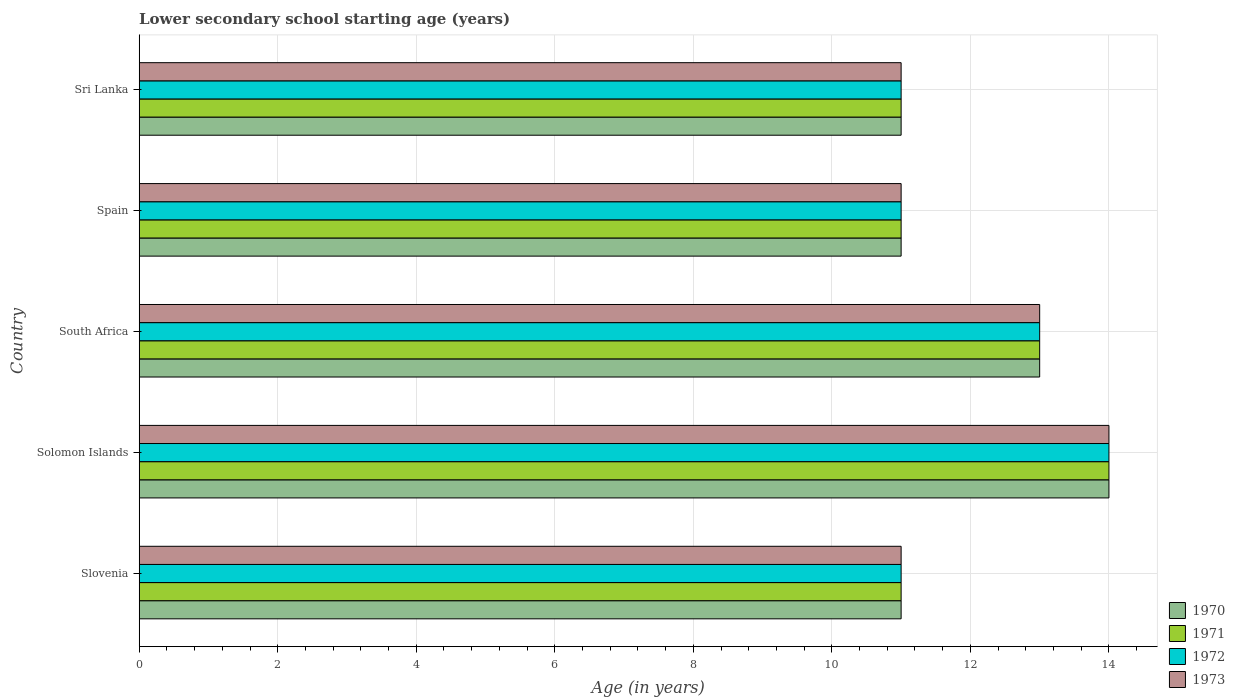How many different coloured bars are there?
Provide a succinct answer. 4. How many groups of bars are there?
Keep it short and to the point. 5. Are the number of bars per tick equal to the number of legend labels?
Give a very brief answer. Yes. How many bars are there on the 4th tick from the bottom?
Provide a short and direct response. 4. What is the label of the 3rd group of bars from the top?
Offer a very short reply. South Africa. In how many cases, is the number of bars for a given country not equal to the number of legend labels?
Make the answer very short. 0. Across all countries, what is the maximum lower secondary school starting age of children in 1971?
Your answer should be compact. 14. Across all countries, what is the minimum lower secondary school starting age of children in 1973?
Keep it short and to the point. 11. In which country was the lower secondary school starting age of children in 1970 maximum?
Provide a succinct answer. Solomon Islands. In which country was the lower secondary school starting age of children in 1972 minimum?
Make the answer very short. Slovenia. What is the difference between the lower secondary school starting age of children in 1970 in Slovenia and the lower secondary school starting age of children in 1971 in Sri Lanka?
Provide a short and direct response. 0. What is the average lower secondary school starting age of children in 1971 per country?
Your answer should be compact. 12. What is the difference between the lower secondary school starting age of children in 1970 and lower secondary school starting age of children in 1973 in South Africa?
Your answer should be very brief. 0. In how many countries, is the lower secondary school starting age of children in 1971 greater than 4.4 years?
Provide a succinct answer. 5. What is the ratio of the lower secondary school starting age of children in 1972 in Solomon Islands to that in South Africa?
Your response must be concise. 1.08. Is the difference between the lower secondary school starting age of children in 1970 in Slovenia and South Africa greater than the difference between the lower secondary school starting age of children in 1973 in Slovenia and South Africa?
Provide a short and direct response. No. In how many countries, is the lower secondary school starting age of children in 1973 greater than the average lower secondary school starting age of children in 1973 taken over all countries?
Make the answer very short. 2. What does the 4th bar from the bottom in Slovenia represents?
Make the answer very short. 1973. How are the legend labels stacked?
Provide a succinct answer. Vertical. What is the title of the graph?
Your response must be concise. Lower secondary school starting age (years). Does "1978" appear as one of the legend labels in the graph?
Give a very brief answer. No. What is the label or title of the X-axis?
Make the answer very short. Age (in years). What is the Age (in years) of 1972 in Slovenia?
Your response must be concise. 11. What is the Age (in years) of 1970 in Solomon Islands?
Offer a terse response. 14. What is the Age (in years) of 1972 in Solomon Islands?
Offer a very short reply. 14. What is the Age (in years) of 1970 in South Africa?
Keep it short and to the point. 13. What is the Age (in years) in 1973 in South Africa?
Your answer should be very brief. 13. What is the Age (in years) of 1971 in Spain?
Your response must be concise. 11. What is the Age (in years) of 1972 in Spain?
Offer a terse response. 11. What is the Age (in years) in 1972 in Sri Lanka?
Your answer should be compact. 11. What is the Age (in years) in 1973 in Sri Lanka?
Make the answer very short. 11. Across all countries, what is the maximum Age (in years) in 1971?
Your answer should be very brief. 14. Across all countries, what is the maximum Age (in years) in 1973?
Provide a succinct answer. 14. Across all countries, what is the minimum Age (in years) in 1972?
Provide a succinct answer. 11. Across all countries, what is the minimum Age (in years) of 1973?
Offer a terse response. 11. What is the total Age (in years) of 1971 in the graph?
Your response must be concise. 60. What is the difference between the Age (in years) of 1970 in Slovenia and that in Solomon Islands?
Offer a very short reply. -3. What is the difference between the Age (in years) of 1971 in Slovenia and that in Spain?
Make the answer very short. 0. What is the difference between the Age (in years) in 1972 in Slovenia and that in Spain?
Your response must be concise. 0. What is the difference between the Age (in years) of 1973 in Slovenia and that in Spain?
Make the answer very short. 0. What is the difference between the Age (in years) of 1971 in Slovenia and that in Sri Lanka?
Your answer should be very brief. 0. What is the difference between the Age (in years) in 1972 in Slovenia and that in Sri Lanka?
Make the answer very short. 0. What is the difference between the Age (in years) in 1973 in Slovenia and that in Sri Lanka?
Provide a succinct answer. 0. What is the difference between the Age (in years) of 1973 in Solomon Islands and that in South Africa?
Your answer should be very brief. 1. What is the difference between the Age (in years) of 1970 in Solomon Islands and that in Spain?
Give a very brief answer. 3. What is the difference between the Age (in years) in 1971 in Solomon Islands and that in Spain?
Give a very brief answer. 3. What is the difference between the Age (in years) of 1973 in Solomon Islands and that in Spain?
Provide a succinct answer. 3. What is the difference between the Age (in years) of 1971 in Solomon Islands and that in Sri Lanka?
Provide a succinct answer. 3. What is the difference between the Age (in years) in 1972 in Solomon Islands and that in Sri Lanka?
Your answer should be compact. 3. What is the difference between the Age (in years) in 1973 in Solomon Islands and that in Sri Lanka?
Offer a terse response. 3. What is the difference between the Age (in years) of 1970 in South Africa and that in Spain?
Give a very brief answer. 2. What is the difference between the Age (in years) in 1971 in South Africa and that in Sri Lanka?
Make the answer very short. 2. What is the difference between the Age (in years) of 1972 in South Africa and that in Sri Lanka?
Provide a succinct answer. 2. What is the difference between the Age (in years) of 1970 in Spain and that in Sri Lanka?
Provide a short and direct response. 0. What is the difference between the Age (in years) of 1971 in Spain and that in Sri Lanka?
Provide a short and direct response. 0. What is the difference between the Age (in years) in 1972 in Spain and that in Sri Lanka?
Give a very brief answer. 0. What is the difference between the Age (in years) of 1970 in Slovenia and the Age (in years) of 1973 in Solomon Islands?
Ensure brevity in your answer.  -3. What is the difference between the Age (in years) of 1971 in Slovenia and the Age (in years) of 1973 in Solomon Islands?
Offer a terse response. -3. What is the difference between the Age (in years) of 1970 in Slovenia and the Age (in years) of 1971 in South Africa?
Offer a terse response. -2. What is the difference between the Age (in years) in 1970 in Slovenia and the Age (in years) in 1972 in South Africa?
Your response must be concise. -2. What is the difference between the Age (in years) in 1971 in Slovenia and the Age (in years) in 1973 in South Africa?
Make the answer very short. -2. What is the difference between the Age (in years) of 1972 in Slovenia and the Age (in years) of 1973 in South Africa?
Your answer should be very brief. -2. What is the difference between the Age (in years) of 1970 in Slovenia and the Age (in years) of 1973 in Sri Lanka?
Your answer should be very brief. 0. What is the difference between the Age (in years) of 1972 in Slovenia and the Age (in years) of 1973 in Sri Lanka?
Your answer should be very brief. 0. What is the difference between the Age (in years) in 1970 in Solomon Islands and the Age (in years) in 1972 in South Africa?
Make the answer very short. 1. What is the difference between the Age (in years) in 1972 in Solomon Islands and the Age (in years) in 1973 in South Africa?
Your answer should be compact. 1. What is the difference between the Age (in years) of 1970 in Solomon Islands and the Age (in years) of 1973 in Spain?
Give a very brief answer. 3. What is the difference between the Age (in years) in 1972 in Solomon Islands and the Age (in years) in 1973 in Spain?
Offer a terse response. 3. What is the difference between the Age (in years) of 1970 in Solomon Islands and the Age (in years) of 1972 in Sri Lanka?
Offer a very short reply. 3. What is the difference between the Age (in years) of 1971 in Solomon Islands and the Age (in years) of 1972 in Sri Lanka?
Your response must be concise. 3. What is the difference between the Age (in years) in 1970 in South Africa and the Age (in years) in 1971 in Spain?
Your answer should be very brief. 2. What is the difference between the Age (in years) of 1970 in South Africa and the Age (in years) of 1972 in Sri Lanka?
Your answer should be very brief. 2. What is the difference between the Age (in years) of 1971 in South Africa and the Age (in years) of 1972 in Sri Lanka?
Keep it short and to the point. 2. What is the difference between the Age (in years) in 1972 in South Africa and the Age (in years) in 1973 in Sri Lanka?
Provide a succinct answer. 2. What is the difference between the Age (in years) of 1970 in Spain and the Age (in years) of 1972 in Sri Lanka?
Make the answer very short. 0. What is the difference between the Age (in years) in 1971 in Spain and the Age (in years) in 1972 in Sri Lanka?
Give a very brief answer. 0. What is the average Age (in years) of 1973 per country?
Your answer should be compact. 12. What is the difference between the Age (in years) in 1970 and Age (in years) in 1972 in Slovenia?
Offer a terse response. 0. What is the difference between the Age (in years) in 1971 and Age (in years) in 1972 in Solomon Islands?
Provide a short and direct response. 0. What is the difference between the Age (in years) of 1971 and Age (in years) of 1973 in Solomon Islands?
Make the answer very short. 0. What is the difference between the Age (in years) in 1972 and Age (in years) in 1973 in Solomon Islands?
Provide a short and direct response. 0. What is the difference between the Age (in years) of 1970 and Age (in years) of 1972 in South Africa?
Give a very brief answer. 0. What is the difference between the Age (in years) of 1970 and Age (in years) of 1973 in South Africa?
Ensure brevity in your answer.  0. What is the difference between the Age (in years) of 1971 and Age (in years) of 1972 in South Africa?
Make the answer very short. 0. What is the difference between the Age (in years) of 1972 and Age (in years) of 1973 in South Africa?
Keep it short and to the point. 0. What is the difference between the Age (in years) in 1970 and Age (in years) in 1971 in Spain?
Give a very brief answer. 0. What is the difference between the Age (in years) in 1970 and Age (in years) in 1972 in Spain?
Ensure brevity in your answer.  0. What is the difference between the Age (in years) of 1970 and Age (in years) of 1973 in Spain?
Your answer should be compact. 0. What is the difference between the Age (in years) of 1971 and Age (in years) of 1973 in Spain?
Provide a short and direct response. 0. What is the difference between the Age (in years) in 1972 and Age (in years) in 1973 in Spain?
Keep it short and to the point. 0. What is the difference between the Age (in years) of 1970 and Age (in years) of 1971 in Sri Lanka?
Provide a short and direct response. 0. What is the difference between the Age (in years) in 1970 and Age (in years) in 1972 in Sri Lanka?
Ensure brevity in your answer.  0. What is the difference between the Age (in years) of 1971 and Age (in years) of 1972 in Sri Lanka?
Your response must be concise. 0. What is the difference between the Age (in years) of 1972 and Age (in years) of 1973 in Sri Lanka?
Provide a short and direct response. 0. What is the ratio of the Age (in years) of 1970 in Slovenia to that in Solomon Islands?
Your answer should be very brief. 0.79. What is the ratio of the Age (in years) of 1971 in Slovenia to that in Solomon Islands?
Offer a terse response. 0.79. What is the ratio of the Age (in years) of 1972 in Slovenia to that in Solomon Islands?
Provide a short and direct response. 0.79. What is the ratio of the Age (in years) in 1973 in Slovenia to that in Solomon Islands?
Provide a succinct answer. 0.79. What is the ratio of the Age (in years) of 1970 in Slovenia to that in South Africa?
Your response must be concise. 0.85. What is the ratio of the Age (in years) in 1971 in Slovenia to that in South Africa?
Ensure brevity in your answer.  0.85. What is the ratio of the Age (in years) in 1972 in Slovenia to that in South Africa?
Your answer should be very brief. 0.85. What is the ratio of the Age (in years) in 1973 in Slovenia to that in South Africa?
Your response must be concise. 0.85. What is the ratio of the Age (in years) of 1973 in Slovenia to that in Spain?
Offer a terse response. 1. What is the ratio of the Age (in years) of 1970 in Slovenia to that in Sri Lanka?
Offer a very short reply. 1. What is the ratio of the Age (in years) in 1971 in Slovenia to that in Sri Lanka?
Provide a short and direct response. 1. What is the ratio of the Age (in years) in 1972 in Slovenia to that in Sri Lanka?
Provide a short and direct response. 1. What is the ratio of the Age (in years) in 1973 in Slovenia to that in Sri Lanka?
Give a very brief answer. 1. What is the ratio of the Age (in years) in 1972 in Solomon Islands to that in South Africa?
Provide a succinct answer. 1.08. What is the ratio of the Age (in years) in 1973 in Solomon Islands to that in South Africa?
Your answer should be very brief. 1.08. What is the ratio of the Age (in years) in 1970 in Solomon Islands to that in Spain?
Your response must be concise. 1.27. What is the ratio of the Age (in years) of 1971 in Solomon Islands to that in Spain?
Your answer should be compact. 1.27. What is the ratio of the Age (in years) in 1972 in Solomon Islands to that in Spain?
Make the answer very short. 1.27. What is the ratio of the Age (in years) of 1973 in Solomon Islands to that in Spain?
Keep it short and to the point. 1.27. What is the ratio of the Age (in years) in 1970 in Solomon Islands to that in Sri Lanka?
Your answer should be very brief. 1.27. What is the ratio of the Age (in years) in 1971 in Solomon Islands to that in Sri Lanka?
Offer a terse response. 1.27. What is the ratio of the Age (in years) in 1972 in Solomon Islands to that in Sri Lanka?
Give a very brief answer. 1.27. What is the ratio of the Age (in years) in 1973 in Solomon Islands to that in Sri Lanka?
Offer a very short reply. 1.27. What is the ratio of the Age (in years) of 1970 in South Africa to that in Spain?
Ensure brevity in your answer.  1.18. What is the ratio of the Age (in years) of 1971 in South Africa to that in Spain?
Ensure brevity in your answer.  1.18. What is the ratio of the Age (in years) in 1972 in South Africa to that in Spain?
Your answer should be compact. 1.18. What is the ratio of the Age (in years) in 1973 in South Africa to that in Spain?
Your response must be concise. 1.18. What is the ratio of the Age (in years) of 1970 in South Africa to that in Sri Lanka?
Give a very brief answer. 1.18. What is the ratio of the Age (in years) in 1971 in South Africa to that in Sri Lanka?
Give a very brief answer. 1.18. What is the ratio of the Age (in years) in 1972 in South Africa to that in Sri Lanka?
Make the answer very short. 1.18. What is the ratio of the Age (in years) of 1973 in South Africa to that in Sri Lanka?
Your answer should be very brief. 1.18. What is the ratio of the Age (in years) of 1971 in Spain to that in Sri Lanka?
Give a very brief answer. 1. What is the ratio of the Age (in years) of 1972 in Spain to that in Sri Lanka?
Your answer should be compact. 1. What is the ratio of the Age (in years) of 1973 in Spain to that in Sri Lanka?
Your answer should be compact. 1. What is the difference between the highest and the second highest Age (in years) in 1970?
Your answer should be very brief. 1. What is the difference between the highest and the lowest Age (in years) of 1971?
Give a very brief answer. 3. 